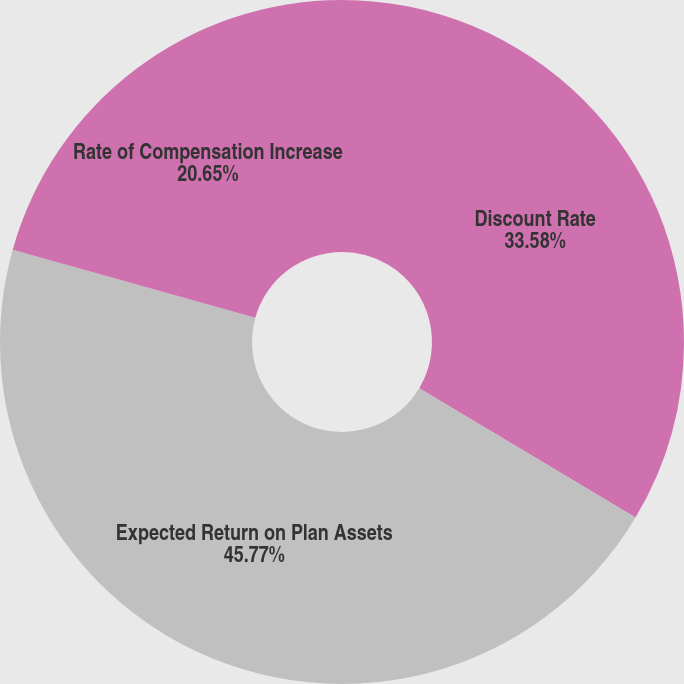Convert chart to OTSL. <chart><loc_0><loc_0><loc_500><loc_500><pie_chart><fcel>Discount Rate<fcel>Expected Return on Plan Assets<fcel>Rate of Compensation Increase<nl><fcel>33.58%<fcel>45.77%<fcel>20.65%<nl></chart> 